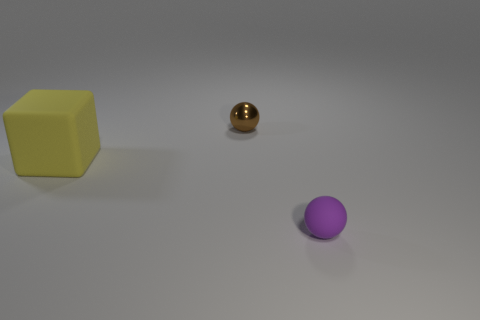There is a object that is behind the big rubber object; does it have the same size as the matte object in front of the yellow object?
Your response must be concise. Yes. What is the thing that is in front of the tiny metallic sphere and right of the large matte thing made of?
Keep it short and to the point. Rubber. What number of other things are the same size as the purple object?
Give a very brief answer. 1. What is the material of the yellow thing to the left of the rubber ball?
Keep it short and to the point. Rubber. Is the shape of the purple object the same as the brown shiny thing?
Give a very brief answer. Yes. What number of other objects are the same shape as the tiny brown metallic thing?
Offer a very short reply. 1. There is a sphere on the left side of the small rubber thing; what is its color?
Ensure brevity in your answer.  Brown. Do the brown metallic sphere and the purple matte sphere have the same size?
Provide a short and direct response. Yes. There is a sphere that is to the right of the thing behind the big yellow rubber block; what is it made of?
Offer a terse response. Rubber. What number of tiny shiny objects have the same color as the shiny sphere?
Your answer should be very brief. 0. 